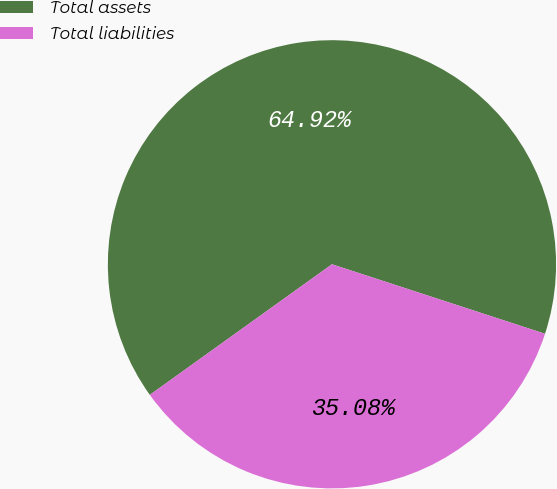Convert chart to OTSL. <chart><loc_0><loc_0><loc_500><loc_500><pie_chart><fcel>Total assets<fcel>Total liabilities<nl><fcel>64.92%<fcel>35.08%<nl></chart> 